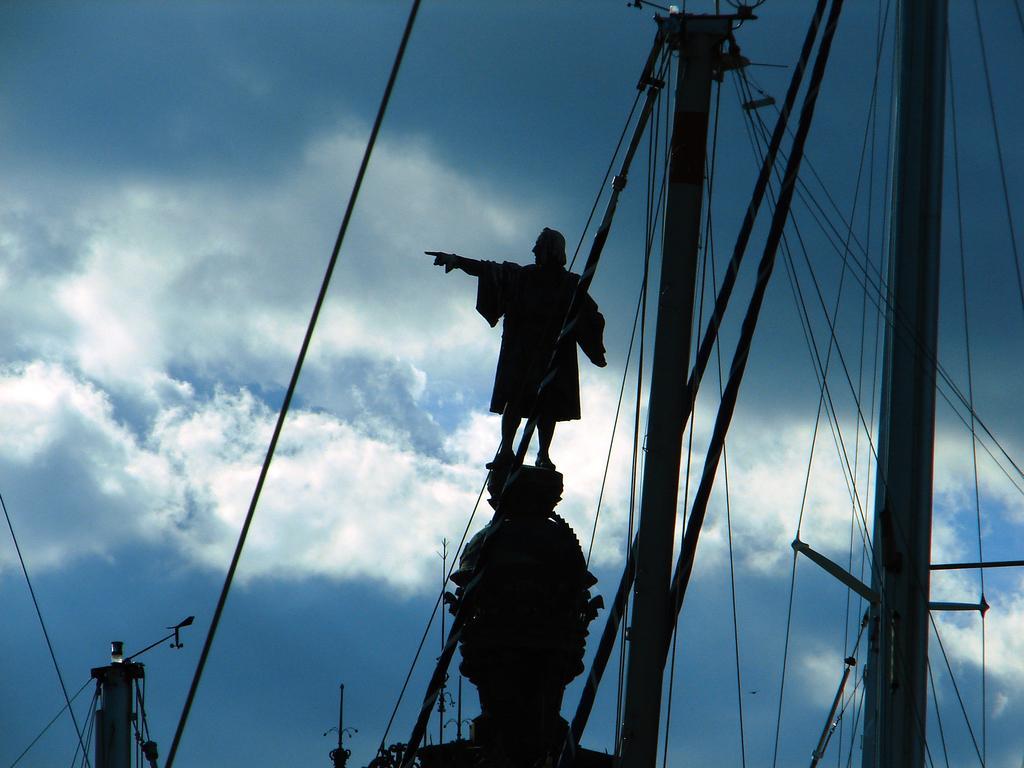How would you summarize this image in a sentence or two? In this picture we can see the man statue in the middle of the image. In the front bottom side there are many poles and cables. Behind we can see sky and clouds. 